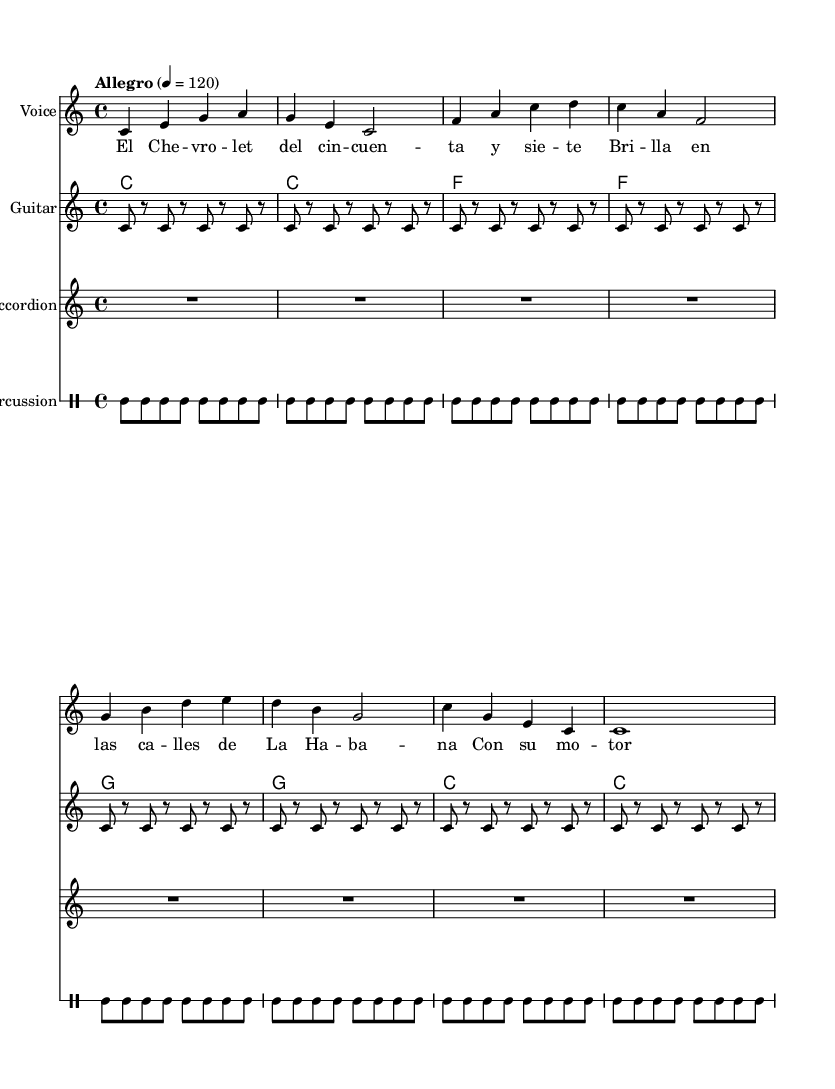What is the key signature of this music? The key signature is C major, which has no sharps or flats.
Answer: C major What is the time signature of this music? The time signature is indicated at the beginning of the score as 4/4, meaning there are four beats in each measure and the quarter note gets one beat.
Answer: 4/4 What is the tempo marking for this piece? The tempo marking states "Allegro" and is set at 4 = 120, indicating a lively and fast pace at 120 beats per minute.
Answer: Allegro How many measures are in the first voice section? By counting the individual sets of notes separated by the vertical lines (bar lines), we can see that there are 8 measures in the first voice section.
Answer: 8 What instruments are featured in this sheet music? The instruments are noted at the beginning of each staff and include Voice, Guitar, Accordion, and Percussion.
Answer: Voice, Guitar, Accordion, Percussion What chord is played in the first measure? The first measure's chord is identified as "c1," indicating a C major chord which is played for a whole note duration.
Answer: C major 